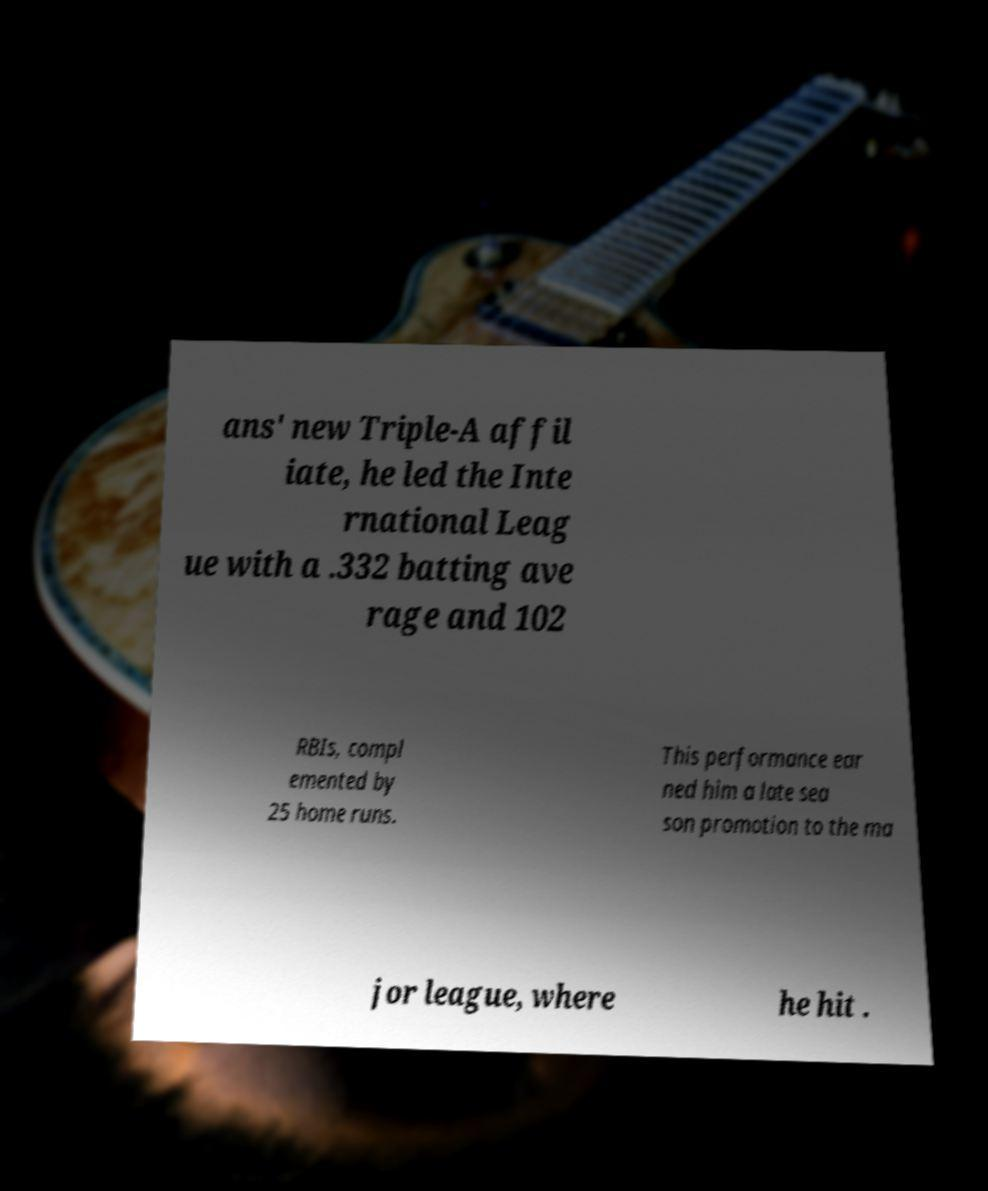For documentation purposes, I need the text within this image transcribed. Could you provide that? ans' new Triple-A affil iate, he led the Inte rnational Leag ue with a .332 batting ave rage and 102 RBIs, compl emented by 25 home runs. This performance ear ned him a late sea son promotion to the ma jor league, where he hit . 